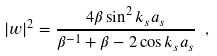<formula> <loc_0><loc_0><loc_500><loc_500>| w | ^ { 2 } = \frac { 4 \beta \sin ^ { 2 } k _ { s } a _ { s } } { \beta ^ { - 1 } + \beta - 2 \cos k _ { s } a _ { s } } \ ,</formula> 